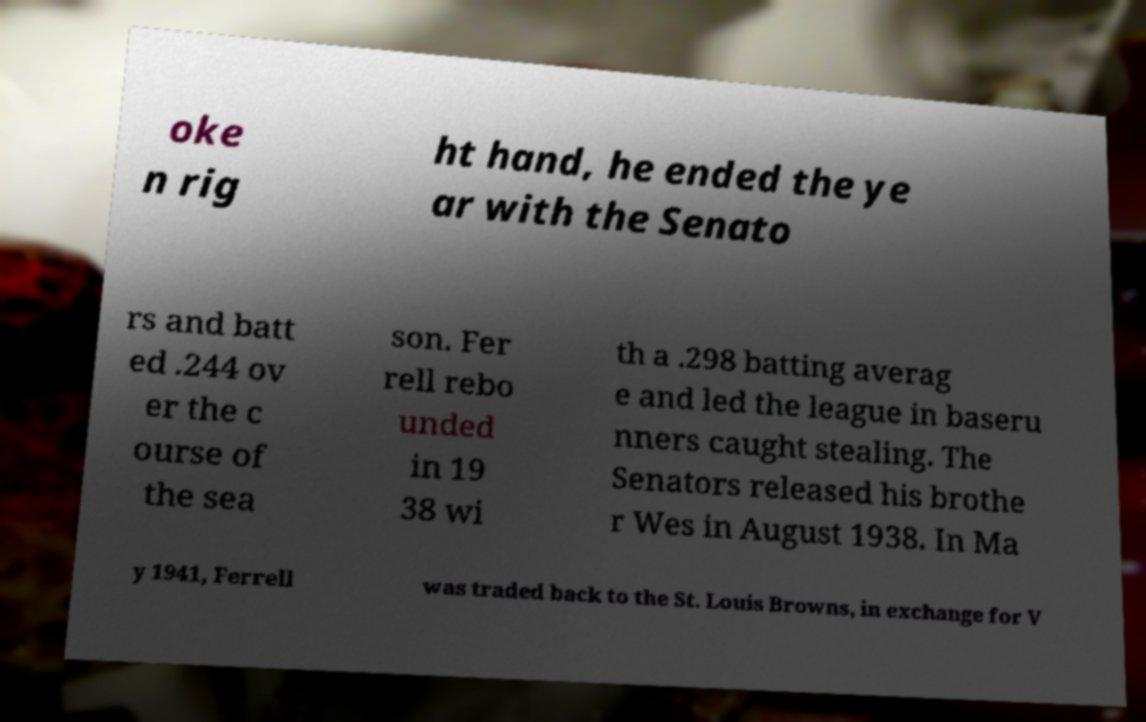Could you extract and type out the text from this image? oke n rig ht hand, he ended the ye ar with the Senato rs and batt ed .244 ov er the c ourse of the sea son. Fer rell rebo unded in 19 38 wi th a .298 batting averag e and led the league in baseru nners caught stealing. The Senators released his brothe r Wes in August 1938. In Ma y 1941, Ferrell was traded back to the St. Louis Browns, in exchange for V 